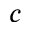Convert formula to latex. <formula><loc_0><loc_0><loc_500><loc_500>c</formula> 